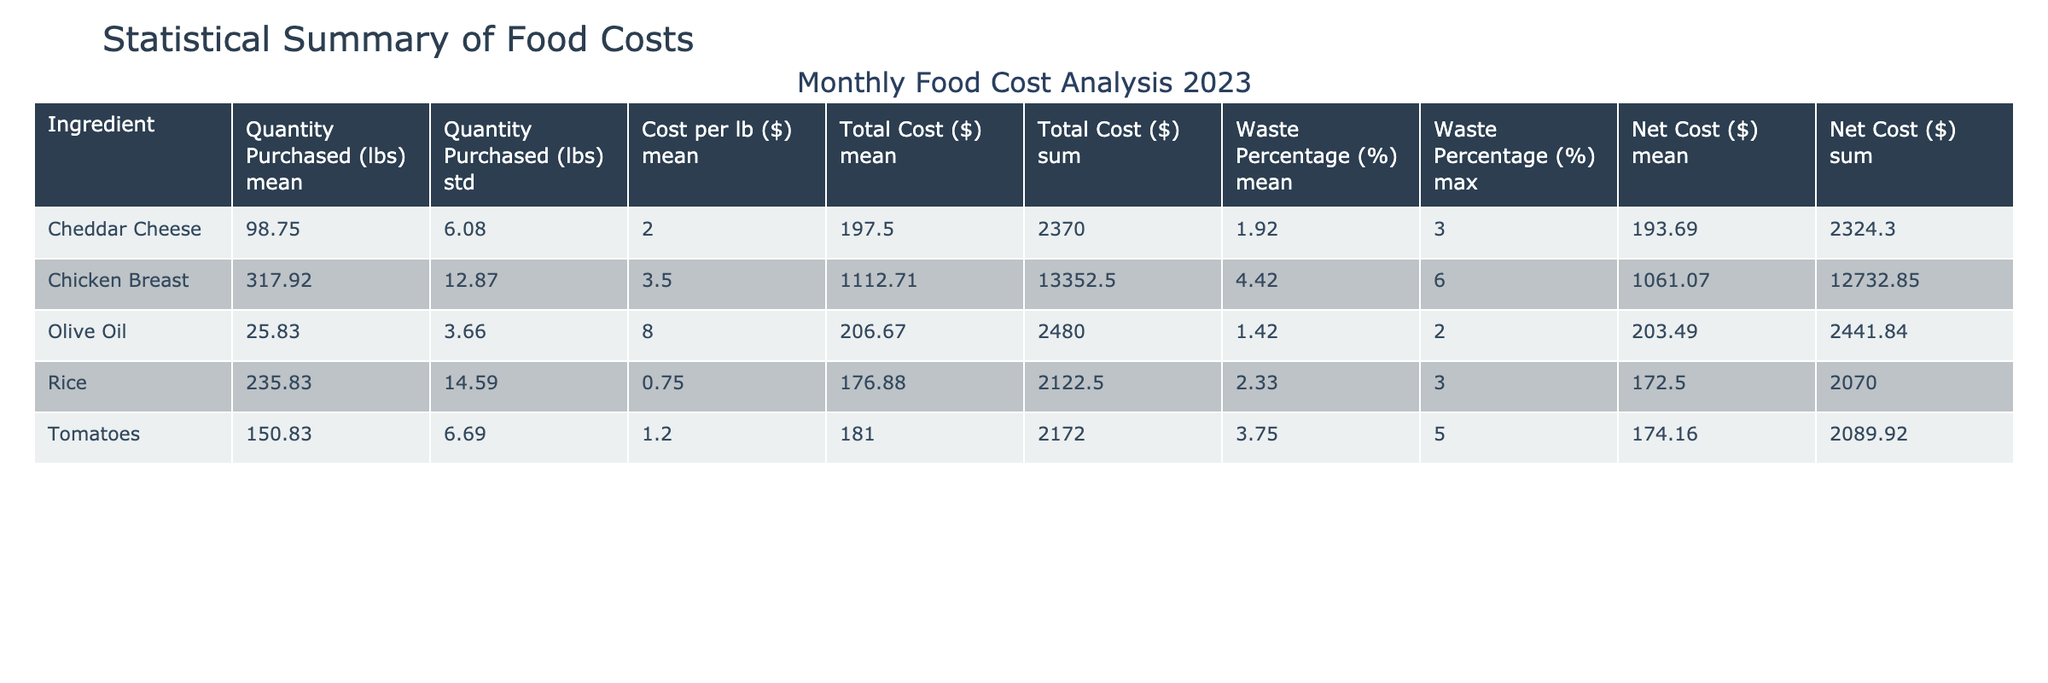What is the total cost of Cheddar Cheese in January? The total cost of Cheddar Cheese in January is directly provided in the table under the "Total Cost ($)" column for January, which is $200.00.
Answer: 200.00 What is the average waste percentage for Tomatoes across all months? To find the average waste percentage, sum the waste percentages for Tomatoes from each month: (4 + 3 + 4 + 4 + 5 + 3 + 4 + 2 + 4 + 5 + 3 + 4) = 46. There are 12 months, so divide by 12 to get the average: 46/12 = 3.83.
Answer: 3.83 Did the cost per lb of Olive Oil remain consistent throughout the year? By looking at the "Cost per lb ($)" column for Olive Oil, it is clear that it is consistently $8.00 for all months. Therefore, the statement is true.
Answer: Yes What is the total net cost for Chicken Breast in the month with the highest quantity purchased? The quantity of Chicken Breast is highest in May at 340 lbs, with a net cost of $1111.00. To answer, we just refer to the table for May's Chicken Breast net cost.
Answer: 1111.00 Which ingredient had the highest average total cost throughout the year? First, calculate the average total cost for each ingredient: Chicken Breast, Rice, Tomatoes, Cheddar Cheese, and Olive Oil based on monthly totals, then compare values. After calculation, Chicken Breast has the highest average total cost at $1104.17.
Answer: Chicken Breast What is the difference between the net cost of Olive Oil in April and December? The net cost of Olive Oil in April is $235.20 and in December is $236.40. The difference is calculated by finding $236.40 - $235.20 = $1.20.
Answer: 1.20 Is the average cost per lb of Rice higher than that of Tomatoes? The average cost per lb of Rice is $0.75 and for Tomatoes is $1.20, thus it can be concluded that $0.75 < $1.20, making the statement false.
Answer: No What ingredient shows a reduction in both total cost and net cost between the months of January and December? By comparing the total costs and net costs for each ingredient in January and December, Rice shows a reduction from $150 to $180 for total cost and from $147.00 to $174.60 for net cost, confirming both reductions.
Answer: Rice 